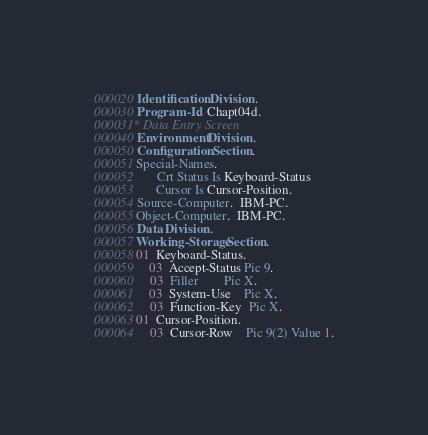Convert code to text. <code><loc_0><loc_0><loc_500><loc_500><_COBOL_>000020 Identification Division.
000030 Program-Id.  Chapt04d.
000031* Data Entry Screen
000040 Environment Division.
000050 Configuration Section.
000051 Special-Names.
000052       Crt Status Is Keyboard-Status
000053       Cursor Is Cursor-Position.
000054 Source-Computer.  IBM-PC.
000055 Object-Computer.  IBM-PC.
000056 Data Division.
000057 Working-Storage Section.
000058 01  Keyboard-Status.
000059     03  Accept-Status Pic 9.
000060     03  Filler        Pic X.
000061     03  System-Use    Pic X.
000062     03  Function-Key  Pic X.
000063 01  Cursor-Position.
000064     03  Cursor-Row    Pic 9(2) Value 1.</code> 